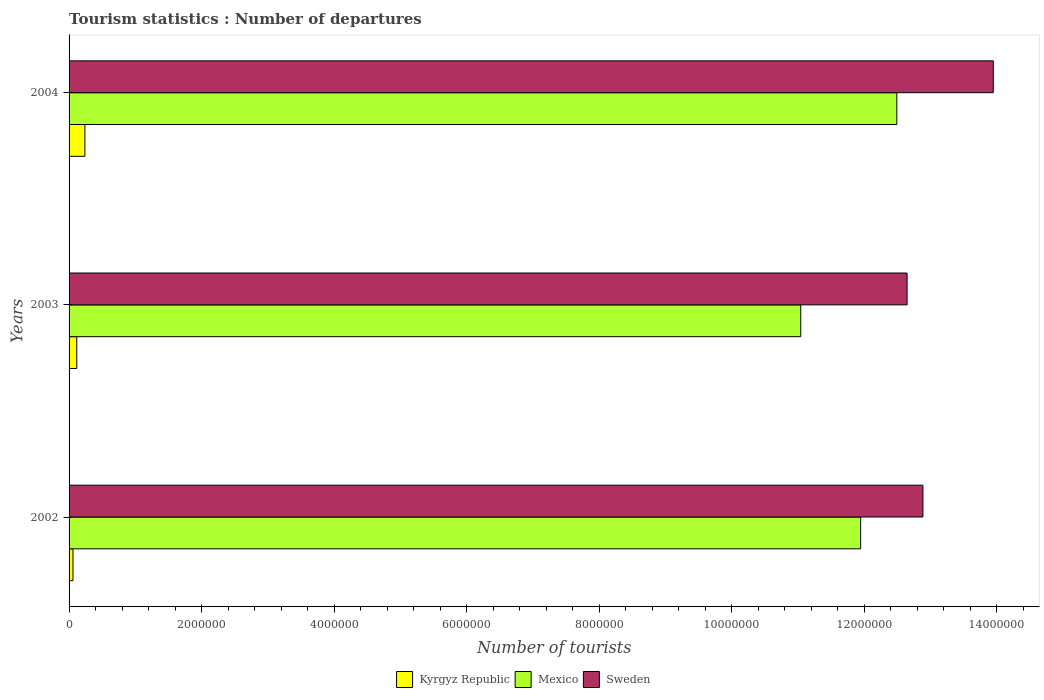How many different coloured bars are there?
Offer a terse response. 3. How many groups of bars are there?
Keep it short and to the point. 3. Are the number of bars on each tick of the Y-axis equal?
Make the answer very short. Yes. How many bars are there on the 2nd tick from the top?
Make the answer very short. 3. How many bars are there on the 1st tick from the bottom?
Provide a succinct answer. 3. What is the number of tourist departures in Kyrgyz Republic in 2004?
Ensure brevity in your answer.  2.39e+05. Across all years, what is the maximum number of tourist departures in Kyrgyz Republic?
Offer a terse response. 2.39e+05. Across all years, what is the minimum number of tourist departures in Sweden?
Give a very brief answer. 1.26e+07. What is the total number of tourist departures in Sweden in the graph?
Give a very brief answer. 3.95e+07. What is the difference between the number of tourist departures in Kyrgyz Republic in 2002 and that in 2003?
Provide a short and direct response. -5.70e+04. What is the difference between the number of tourist departures in Sweden in 2004 and the number of tourist departures in Kyrgyz Republic in 2003?
Your answer should be compact. 1.38e+07. What is the average number of tourist departures in Mexico per year?
Give a very brief answer. 1.18e+07. In the year 2004, what is the difference between the number of tourist departures in Mexico and number of tourist departures in Sweden?
Ensure brevity in your answer.  -1.46e+06. What is the ratio of the number of tourist departures in Mexico in 2002 to that in 2003?
Provide a succinct answer. 1.08. Is the difference between the number of tourist departures in Mexico in 2002 and 2004 greater than the difference between the number of tourist departures in Sweden in 2002 and 2004?
Provide a succinct answer. Yes. What is the difference between the highest and the second highest number of tourist departures in Sweden?
Offer a very short reply. 1.06e+06. What does the 2nd bar from the top in 2004 represents?
Make the answer very short. Mexico. Is it the case that in every year, the sum of the number of tourist departures in Kyrgyz Republic and number of tourist departures in Mexico is greater than the number of tourist departures in Sweden?
Provide a short and direct response. No. How many bars are there?
Keep it short and to the point. 9. Are all the bars in the graph horizontal?
Give a very brief answer. Yes. How many years are there in the graph?
Offer a very short reply. 3. What is the difference between two consecutive major ticks on the X-axis?
Make the answer very short. 2.00e+06. Are the values on the major ticks of X-axis written in scientific E-notation?
Provide a succinct answer. No. Does the graph contain any zero values?
Keep it short and to the point. No. Does the graph contain grids?
Provide a short and direct response. No. Where does the legend appear in the graph?
Provide a short and direct response. Bottom center. How are the legend labels stacked?
Make the answer very short. Horizontal. What is the title of the graph?
Ensure brevity in your answer.  Tourism statistics : Number of departures. Does "Heavily indebted poor countries" appear as one of the legend labels in the graph?
Make the answer very short. No. What is the label or title of the X-axis?
Offer a very short reply. Number of tourists. What is the Number of tourists of Kyrgyz Republic in 2002?
Provide a short and direct response. 5.90e+04. What is the Number of tourists in Mexico in 2002?
Keep it short and to the point. 1.19e+07. What is the Number of tourists in Sweden in 2002?
Your answer should be compact. 1.29e+07. What is the Number of tourists in Kyrgyz Republic in 2003?
Your answer should be compact. 1.16e+05. What is the Number of tourists in Mexico in 2003?
Provide a short and direct response. 1.10e+07. What is the Number of tourists in Sweden in 2003?
Provide a succinct answer. 1.26e+07. What is the Number of tourists in Kyrgyz Republic in 2004?
Provide a short and direct response. 2.39e+05. What is the Number of tourists of Mexico in 2004?
Offer a terse response. 1.25e+07. What is the Number of tourists of Sweden in 2004?
Your answer should be compact. 1.40e+07. Across all years, what is the maximum Number of tourists in Kyrgyz Republic?
Make the answer very short. 2.39e+05. Across all years, what is the maximum Number of tourists of Mexico?
Keep it short and to the point. 1.25e+07. Across all years, what is the maximum Number of tourists of Sweden?
Ensure brevity in your answer.  1.40e+07. Across all years, what is the minimum Number of tourists in Kyrgyz Republic?
Your answer should be compact. 5.90e+04. Across all years, what is the minimum Number of tourists of Mexico?
Make the answer very short. 1.10e+07. Across all years, what is the minimum Number of tourists of Sweden?
Make the answer very short. 1.26e+07. What is the total Number of tourists of Kyrgyz Republic in the graph?
Offer a very short reply. 4.14e+05. What is the total Number of tourists in Mexico in the graph?
Ensure brevity in your answer.  3.55e+07. What is the total Number of tourists in Sweden in the graph?
Provide a succinct answer. 3.95e+07. What is the difference between the Number of tourists of Kyrgyz Republic in 2002 and that in 2003?
Your answer should be compact. -5.70e+04. What is the difference between the Number of tourists of Mexico in 2002 and that in 2003?
Provide a short and direct response. 9.04e+05. What is the difference between the Number of tourists of Sweden in 2002 and that in 2003?
Give a very brief answer. 2.39e+05. What is the difference between the Number of tourists of Mexico in 2002 and that in 2004?
Give a very brief answer. -5.46e+05. What is the difference between the Number of tourists of Sweden in 2002 and that in 2004?
Provide a succinct answer. -1.06e+06. What is the difference between the Number of tourists of Kyrgyz Republic in 2003 and that in 2004?
Offer a terse response. -1.23e+05. What is the difference between the Number of tourists of Mexico in 2003 and that in 2004?
Your response must be concise. -1.45e+06. What is the difference between the Number of tourists of Sweden in 2003 and that in 2004?
Provide a short and direct response. -1.30e+06. What is the difference between the Number of tourists in Kyrgyz Republic in 2002 and the Number of tourists in Mexico in 2003?
Keep it short and to the point. -1.10e+07. What is the difference between the Number of tourists of Kyrgyz Republic in 2002 and the Number of tourists of Sweden in 2003?
Provide a short and direct response. -1.26e+07. What is the difference between the Number of tourists in Mexico in 2002 and the Number of tourists in Sweden in 2003?
Make the answer very short. -7.01e+05. What is the difference between the Number of tourists of Kyrgyz Republic in 2002 and the Number of tourists of Mexico in 2004?
Offer a terse response. -1.24e+07. What is the difference between the Number of tourists of Kyrgyz Republic in 2002 and the Number of tourists of Sweden in 2004?
Ensure brevity in your answer.  -1.39e+07. What is the difference between the Number of tourists of Mexico in 2002 and the Number of tourists of Sweden in 2004?
Your response must be concise. -2.00e+06. What is the difference between the Number of tourists of Kyrgyz Republic in 2003 and the Number of tourists of Mexico in 2004?
Your answer should be very brief. -1.24e+07. What is the difference between the Number of tourists in Kyrgyz Republic in 2003 and the Number of tourists in Sweden in 2004?
Your answer should be very brief. -1.38e+07. What is the difference between the Number of tourists of Mexico in 2003 and the Number of tourists of Sweden in 2004?
Your response must be concise. -2.91e+06. What is the average Number of tourists in Kyrgyz Republic per year?
Your answer should be compact. 1.38e+05. What is the average Number of tourists in Mexico per year?
Your answer should be very brief. 1.18e+07. What is the average Number of tourists of Sweden per year?
Provide a short and direct response. 1.32e+07. In the year 2002, what is the difference between the Number of tourists in Kyrgyz Republic and Number of tourists in Mexico?
Your answer should be very brief. -1.19e+07. In the year 2002, what is the difference between the Number of tourists in Kyrgyz Republic and Number of tourists in Sweden?
Offer a very short reply. -1.28e+07. In the year 2002, what is the difference between the Number of tourists of Mexico and Number of tourists of Sweden?
Give a very brief answer. -9.40e+05. In the year 2003, what is the difference between the Number of tourists of Kyrgyz Republic and Number of tourists of Mexico?
Provide a short and direct response. -1.09e+07. In the year 2003, what is the difference between the Number of tourists of Kyrgyz Republic and Number of tourists of Sweden?
Offer a terse response. -1.25e+07. In the year 2003, what is the difference between the Number of tourists of Mexico and Number of tourists of Sweden?
Keep it short and to the point. -1.60e+06. In the year 2004, what is the difference between the Number of tourists in Kyrgyz Republic and Number of tourists in Mexico?
Make the answer very short. -1.23e+07. In the year 2004, what is the difference between the Number of tourists of Kyrgyz Republic and Number of tourists of Sweden?
Your response must be concise. -1.37e+07. In the year 2004, what is the difference between the Number of tourists of Mexico and Number of tourists of Sweden?
Your answer should be very brief. -1.46e+06. What is the ratio of the Number of tourists of Kyrgyz Republic in 2002 to that in 2003?
Provide a short and direct response. 0.51. What is the ratio of the Number of tourists of Mexico in 2002 to that in 2003?
Make the answer very short. 1.08. What is the ratio of the Number of tourists of Sweden in 2002 to that in 2003?
Your answer should be very brief. 1.02. What is the ratio of the Number of tourists in Kyrgyz Republic in 2002 to that in 2004?
Offer a very short reply. 0.25. What is the ratio of the Number of tourists in Mexico in 2002 to that in 2004?
Your answer should be very brief. 0.96. What is the ratio of the Number of tourists in Sweden in 2002 to that in 2004?
Your response must be concise. 0.92. What is the ratio of the Number of tourists of Kyrgyz Republic in 2003 to that in 2004?
Give a very brief answer. 0.49. What is the ratio of the Number of tourists in Mexico in 2003 to that in 2004?
Your answer should be very brief. 0.88. What is the ratio of the Number of tourists of Sweden in 2003 to that in 2004?
Make the answer very short. 0.91. What is the difference between the highest and the second highest Number of tourists of Kyrgyz Republic?
Your response must be concise. 1.23e+05. What is the difference between the highest and the second highest Number of tourists of Mexico?
Your response must be concise. 5.46e+05. What is the difference between the highest and the second highest Number of tourists in Sweden?
Your answer should be very brief. 1.06e+06. What is the difference between the highest and the lowest Number of tourists in Kyrgyz Republic?
Provide a succinct answer. 1.80e+05. What is the difference between the highest and the lowest Number of tourists in Mexico?
Your response must be concise. 1.45e+06. What is the difference between the highest and the lowest Number of tourists in Sweden?
Your response must be concise. 1.30e+06. 